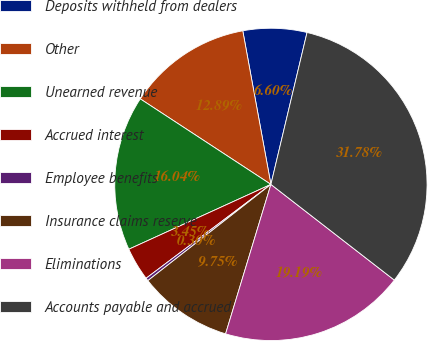<chart> <loc_0><loc_0><loc_500><loc_500><pie_chart><fcel>Deposits withheld from dealers<fcel>Other<fcel>Unearned revenue<fcel>Accrued interest<fcel>Employee benefits<fcel>Insurance claims reserve<fcel>Eliminations<fcel>Accounts payable and accrued<nl><fcel>6.6%<fcel>12.89%<fcel>16.04%<fcel>3.45%<fcel>0.3%<fcel>9.75%<fcel>19.19%<fcel>31.78%<nl></chart> 